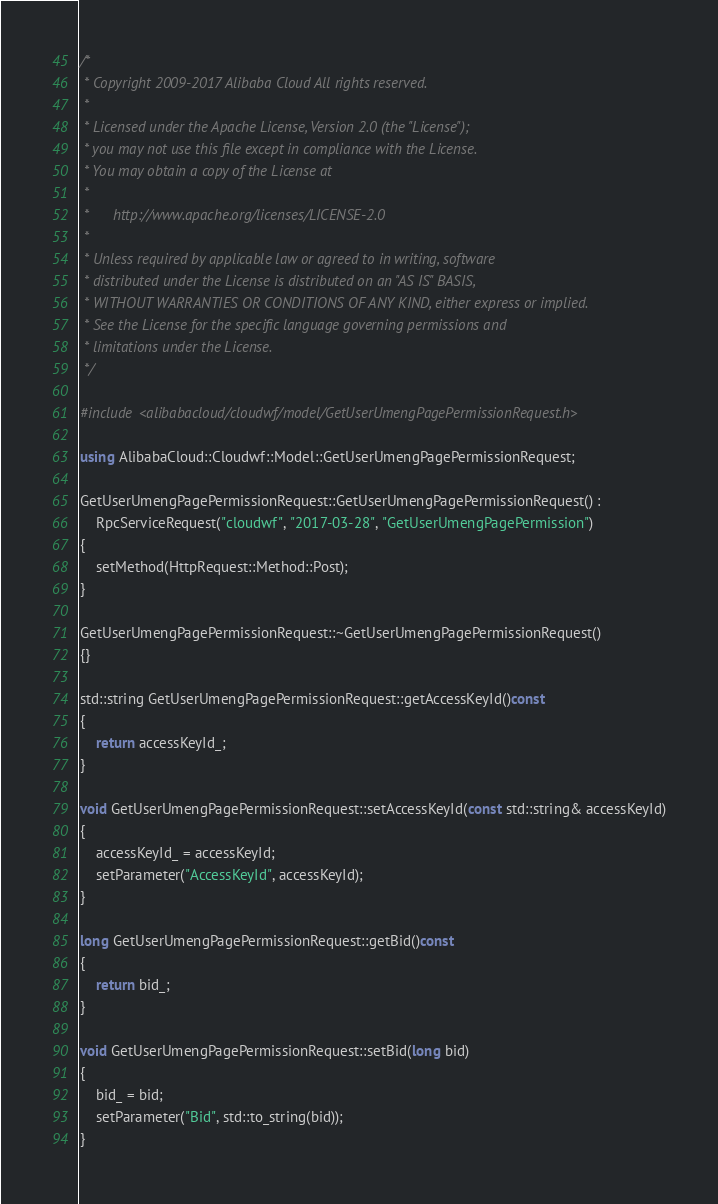Convert code to text. <code><loc_0><loc_0><loc_500><loc_500><_C++_>/*
 * Copyright 2009-2017 Alibaba Cloud All rights reserved.
 * 
 * Licensed under the Apache License, Version 2.0 (the "License");
 * you may not use this file except in compliance with the License.
 * You may obtain a copy of the License at
 * 
 *      http://www.apache.org/licenses/LICENSE-2.0
 * 
 * Unless required by applicable law or agreed to in writing, software
 * distributed under the License is distributed on an "AS IS" BASIS,
 * WITHOUT WARRANTIES OR CONDITIONS OF ANY KIND, either express or implied.
 * See the License for the specific language governing permissions and
 * limitations under the License.
 */

#include <alibabacloud/cloudwf/model/GetUserUmengPagePermissionRequest.h>

using AlibabaCloud::Cloudwf::Model::GetUserUmengPagePermissionRequest;

GetUserUmengPagePermissionRequest::GetUserUmengPagePermissionRequest() :
	RpcServiceRequest("cloudwf", "2017-03-28", "GetUserUmengPagePermission")
{
	setMethod(HttpRequest::Method::Post);
}

GetUserUmengPagePermissionRequest::~GetUserUmengPagePermissionRequest()
{}

std::string GetUserUmengPagePermissionRequest::getAccessKeyId()const
{
	return accessKeyId_;
}

void GetUserUmengPagePermissionRequest::setAccessKeyId(const std::string& accessKeyId)
{
	accessKeyId_ = accessKeyId;
	setParameter("AccessKeyId", accessKeyId);
}

long GetUserUmengPagePermissionRequest::getBid()const
{
	return bid_;
}

void GetUserUmengPagePermissionRequest::setBid(long bid)
{
	bid_ = bid;
	setParameter("Bid", std::to_string(bid));
}

</code> 